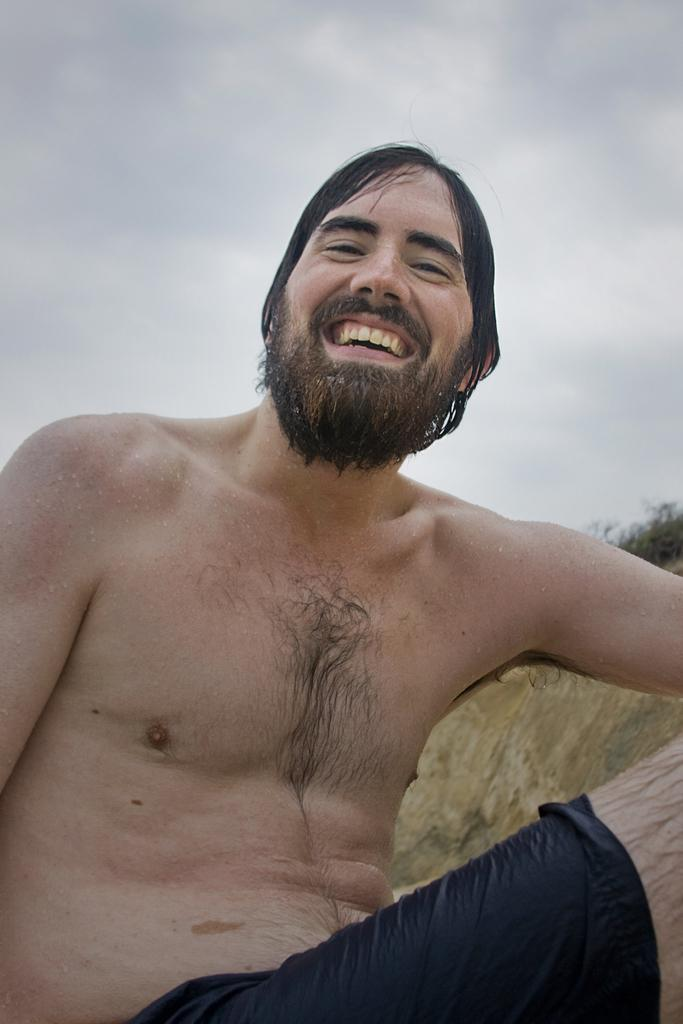What is the man in the image doing? The man is sitting in the image. What expression does the man have? The man is smiling. What can be seen in the background of the image? There might be grass and a tree in the background of the image. What is visible at the top of the image? There are clouds visible at the top of the image. What type of locket is the man wearing in the image? There is no locket visible in the image. What is the position of the man's teeth while he is smiling? The image does not show the man's teeth, so it is not possible to determine their position. 